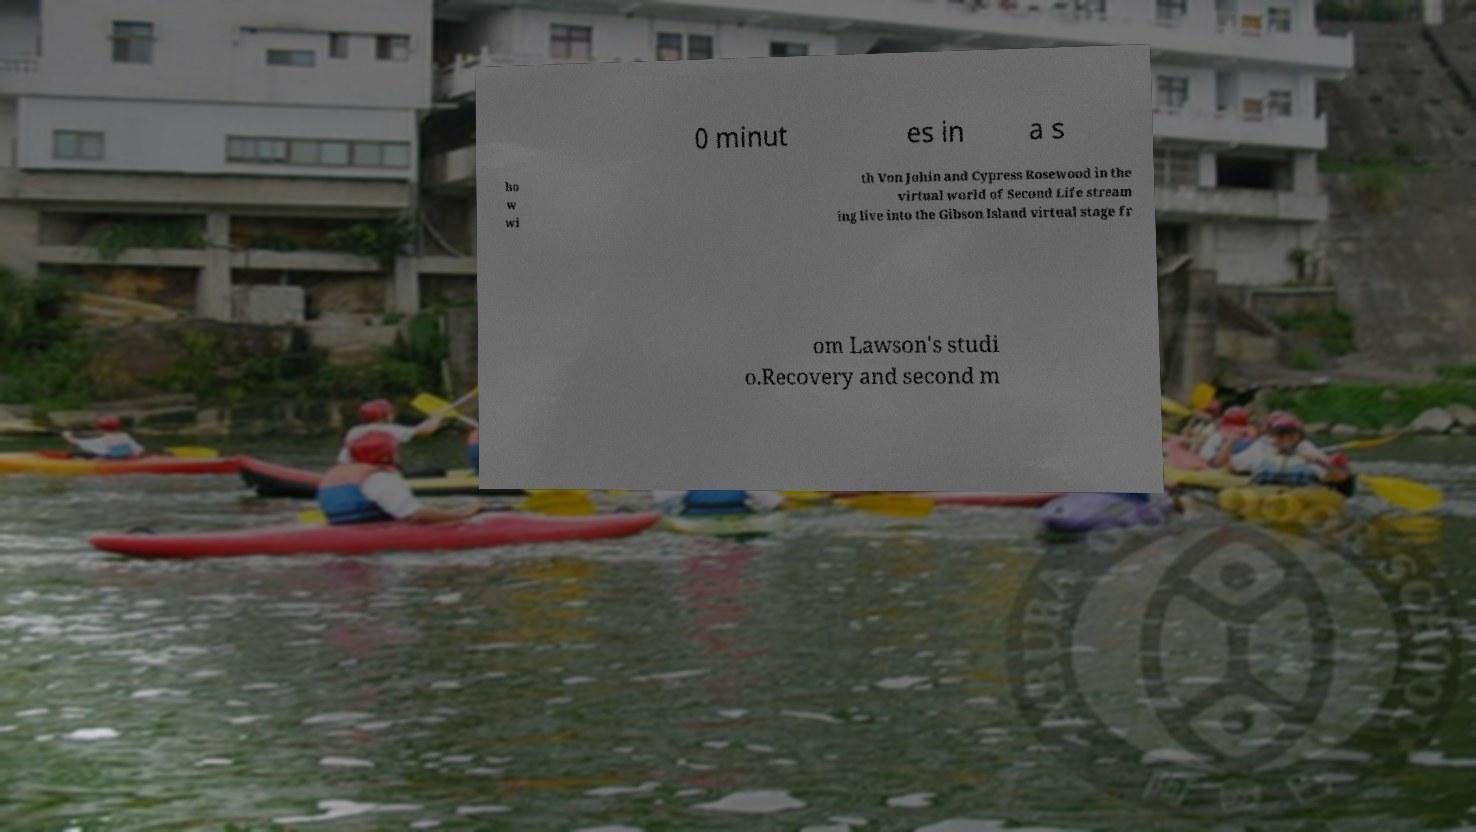I need the written content from this picture converted into text. Can you do that? 0 minut es in a s ho w wi th Von Johin and Cypress Rosewood in the virtual world of Second Life stream ing live into the Gibson Island virtual stage fr om Lawson's studi o.Recovery and second m 